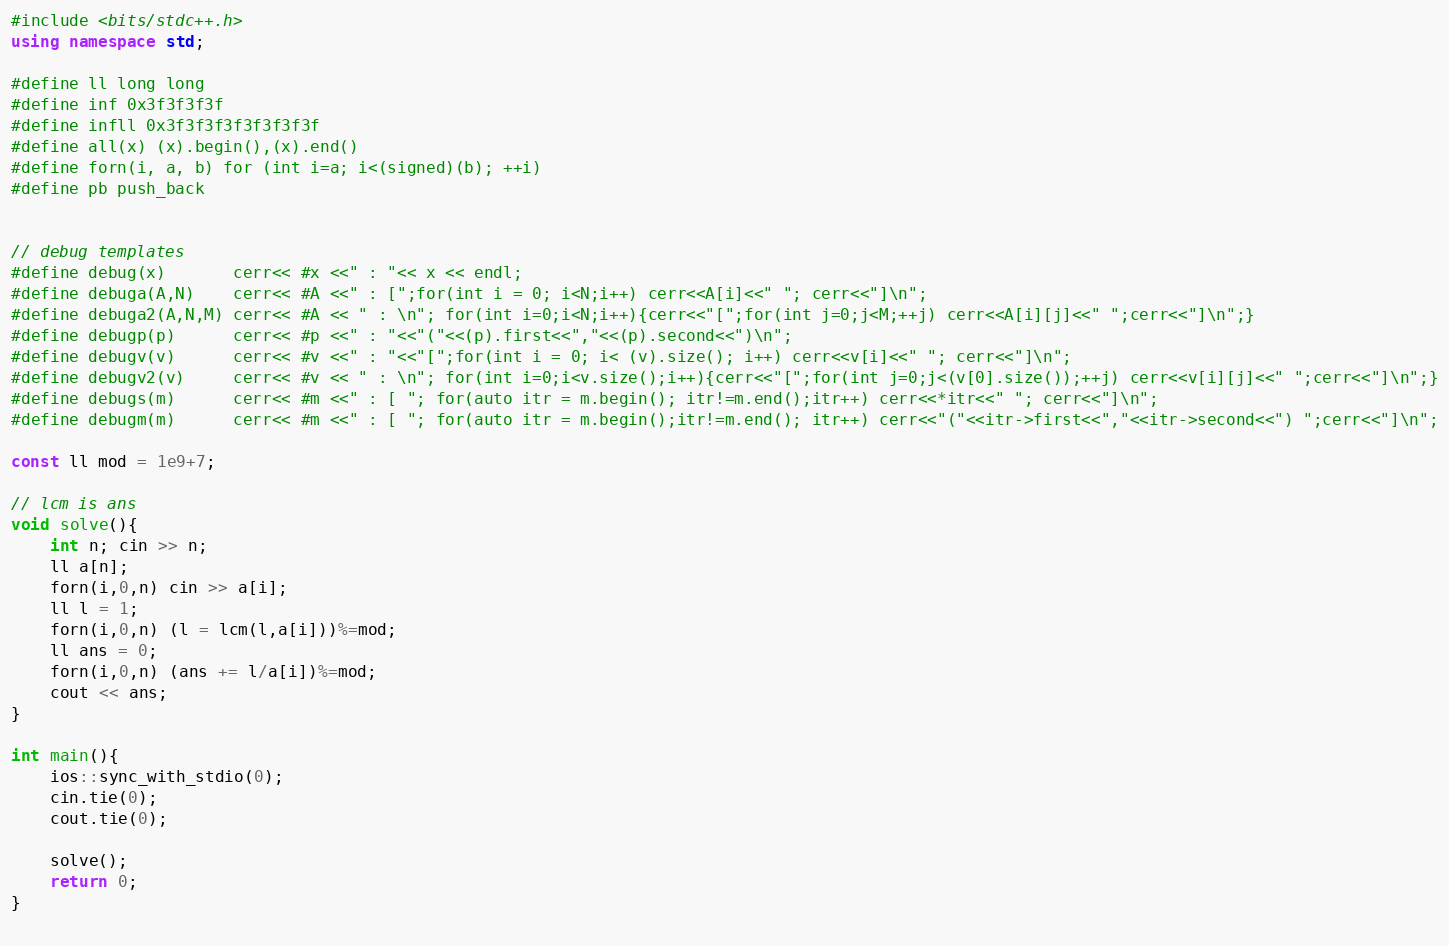Convert code to text. <code><loc_0><loc_0><loc_500><loc_500><_C++_>#include <bits/stdc++.h>
using namespace std;
 
#define ll long long 
#define inf 0x3f3f3f3f
#define infll 0x3f3f3f3f3f3f3f3f
#define all(x) (x).begin(),(x).end()
#define forn(i, a, b) for (int i=a; i<(signed)(b); ++i)
#define pb push_back
 
 
// debug templates 
#define debug(x)       cerr<< #x <<" : "<< x << endl;
#define debuga(A,N)    cerr<< #A <<" : [";for(int i = 0; i<N;i++) cerr<<A[i]<<" "; cerr<<"]\n";
#define debuga2(A,N,M) cerr<< #A << " : \n"; for(int i=0;i<N;i++){cerr<<"[";for(int j=0;j<M;++j) cerr<<A[i][j]<<" ";cerr<<"]\n";}
#define debugp(p)      cerr<< #p <<" : "<<"("<<(p).first<<","<<(p).second<<")\n";
#define debugv(v)      cerr<< #v <<" : "<<"[";for(int i = 0; i< (v).size(); i++) cerr<<v[i]<<" "; cerr<<"]\n";
#define debugv2(v)     cerr<< #v << " : \n"; for(int i=0;i<v.size();i++){cerr<<"[";for(int j=0;j<(v[0].size());++j) cerr<<v[i][j]<<" ";cerr<<"]\n";}
#define debugs(m)      cerr<< #m <<" : [ "; for(auto itr = m.begin(); itr!=m.end();itr++) cerr<<*itr<<" "; cerr<<"]\n";
#define debugm(m)      cerr<< #m <<" : [ "; for(auto itr = m.begin();itr!=m.end(); itr++) cerr<<"("<<itr->first<<","<<itr->second<<") ";cerr<<"]\n";
 
const ll mod = 1e9+7;

// lcm is ans
void solve(){
	int n; cin >> n;
	ll a[n];
	forn(i,0,n) cin >> a[i];
	ll l = 1;
	forn(i,0,n) (l = lcm(l,a[i]))%=mod;
	ll ans = 0;
	forn(i,0,n) (ans += l/a[i])%=mod;
	cout << ans;
}
 
int main(){
	ios::sync_with_stdio(0);
	cin.tie(0);
	cout.tie(0);
	
	solve();
	return 0;
}
 
</code> 